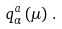<formula> <loc_0><loc_0><loc_500><loc_500>q ^ { a } _ { \alpha } \left ( \mu \right ) \, .</formula> 